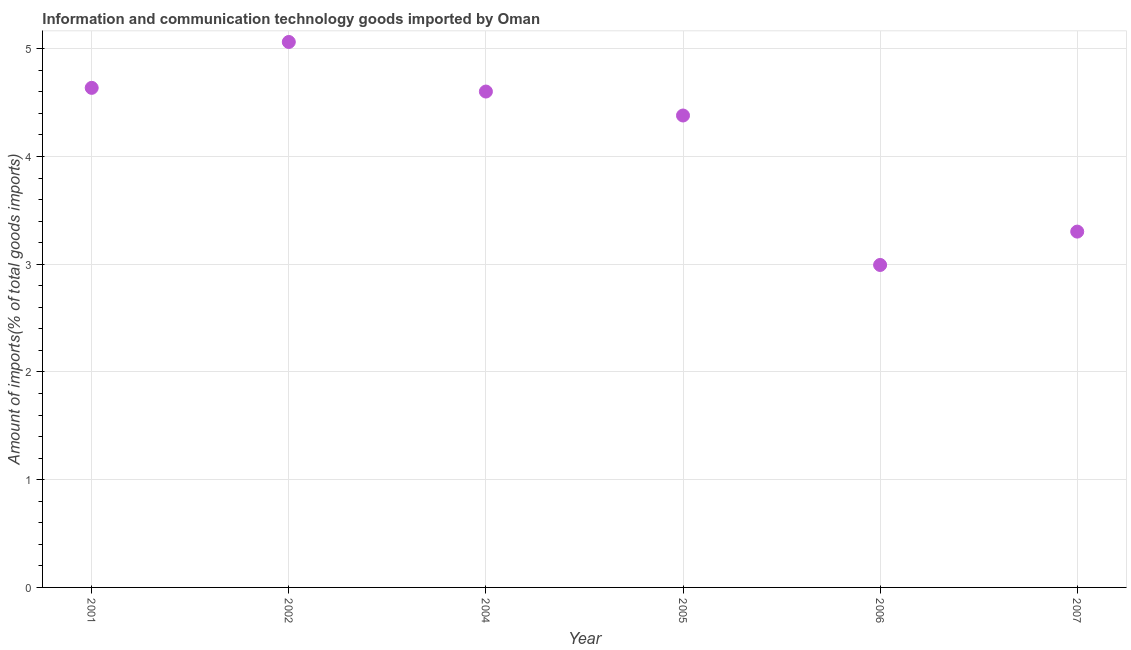What is the amount of ict goods imports in 2005?
Your answer should be very brief. 4.38. Across all years, what is the maximum amount of ict goods imports?
Ensure brevity in your answer.  5.06. Across all years, what is the minimum amount of ict goods imports?
Keep it short and to the point. 2.99. In which year was the amount of ict goods imports maximum?
Your answer should be compact. 2002. What is the sum of the amount of ict goods imports?
Give a very brief answer. 24.98. What is the difference between the amount of ict goods imports in 2001 and 2007?
Keep it short and to the point. 1.33. What is the average amount of ict goods imports per year?
Offer a terse response. 4.16. What is the median amount of ict goods imports?
Your answer should be compact. 4.49. In how many years, is the amount of ict goods imports greater than 2.6 %?
Ensure brevity in your answer.  6. Do a majority of the years between 2006 and 2007 (inclusive) have amount of ict goods imports greater than 3.2 %?
Your response must be concise. No. What is the ratio of the amount of ict goods imports in 2004 to that in 2005?
Provide a short and direct response. 1.05. What is the difference between the highest and the second highest amount of ict goods imports?
Make the answer very short. 0.43. What is the difference between the highest and the lowest amount of ict goods imports?
Your answer should be compact. 2.07. How many dotlines are there?
Provide a short and direct response. 1. What is the difference between two consecutive major ticks on the Y-axis?
Keep it short and to the point. 1. Does the graph contain any zero values?
Provide a succinct answer. No. What is the title of the graph?
Offer a very short reply. Information and communication technology goods imported by Oman. What is the label or title of the X-axis?
Ensure brevity in your answer.  Year. What is the label or title of the Y-axis?
Provide a succinct answer. Amount of imports(% of total goods imports). What is the Amount of imports(% of total goods imports) in 2001?
Offer a terse response. 4.64. What is the Amount of imports(% of total goods imports) in 2002?
Provide a short and direct response. 5.06. What is the Amount of imports(% of total goods imports) in 2004?
Your answer should be very brief. 4.6. What is the Amount of imports(% of total goods imports) in 2005?
Keep it short and to the point. 4.38. What is the Amount of imports(% of total goods imports) in 2006?
Provide a short and direct response. 2.99. What is the Amount of imports(% of total goods imports) in 2007?
Offer a very short reply. 3.3. What is the difference between the Amount of imports(% of total goods imports) in 2001 and 2002?
Your response must be concise. -0.43. What is the difference between the Amount of imports(% of total goods imports) in 2001 and 2004?
Give a very brief answer. 0.03. What is the difference between the Amount of imports(% of total goods imports) in 2001 and 2005?
Offer a very short reply. 0.26. What is the difference between the Amount of imports(% of total goods imports) in 2001 and 2006?
Your response must be concise. 1.64. What is the difference between the Amount of imports(% of total goods imports) in 2001 and 2007?
Make the answer very short. 1.33. What is the difference between the Amount of imports(% of total goods imports) in 2002 and 2004?
Keep it short and to the point. 0.46. What is the difference between the Amount of imports(% of total goods imports) in 2002 and 2005?
Offer a very short reply. 0.68. What is the difference between the Amount of imports(% of total goods imports) in 2002 and 2006?
Provide a short and direct response. 2.07. What is the difference between the Amount of imports(% of total goods imports) in 2002 and 2007?
Provide a short and direct response. 1.76. What is the difference between the Amount of imports(% of total goods imports) in 2004 and 2005?
Ensure brevity in your answer.  0.22. What is the difference between the Amount of imports(% of total goods imports) in 2004 and 2006?
Keep it short and to the point. 1.61. What is the difference between the Amount of imports(% of total goods imports) in 2004 and 2007?
Ensure brevity in your answer.  1.3. What is the difference between the Amount of imports(% of total goods imports) in 2005 and 2006?
Your answer should be very brief. 1.39. What is the difference between the Amount of imports(% of total goods imports) in 2005 and 2007?
Provide a succinct answer. 1.08. What is the difference between the Amount of imports(% of total goods imports) in 2006 and 2007?
Make the answer very short. -0.31. What is the ratio of the Amount of imports(% of total goods imports) in 2001 to that in 2002?
Keep it short and to the point. 0.92. What is the ratio of the Amount of imports(% of total goods imports) in 2001 to that in 2004?
Ensure brevity in your answer.  1.01. What is the ratio of the Amount of imports(% of total goods imports) in 2001 to that in 2005?
Your answer should be compact. 1.06. What is the ratio of the Amount of imports(% of total goods imports) in 2001 to that in 2006?
Your answer should be compact. 1.55. What is the ratio of the Amount of imports(% of total goods imports) in 2001 to that in 2007?
Make the answer very short. 1.4. What is the ratio of the Amount of imports(% of total goods imports) in 2002 to that in 2005?
Provide a succinct answer. 1.16. What is the ratio of the Amount of imports(% of total goods imports) in 2002 to that in 2006?
Give a very brief answer. 1.69. What is the ratio of the Amount of imports(% of total goods imports) in 2002 to that in 2007?
Offer a terse response. 1.53. What is the ratio of the Amount of imports(% of total goods imports) in 2004 to that in 2005?
Ensure brevity in your answer.  1.05. What is the ratio of the Amount of imports(% of total goods imports) in 2004 to that in 2006?
Provide a short and direct response. 1.54. What is the ratio of the Amount of imports(% of total goods imports) in 2004 to that in 2007?
Your response must be concise. 1.39. What is the ratio of the Amount of imports(% of total goods imports) in 2005 to that in 2006?
Ensure brevity in your answer.  1.46. What is the ratio of the Amount of imports(% of total goods imports) in 2005 to that in 2007?
Provide a succinct answer. 1.33. What is the ratio of the Amount of imports(% of total goods imports) in 2006 to that in 2007?
Offer a very short reply. 0.91. 